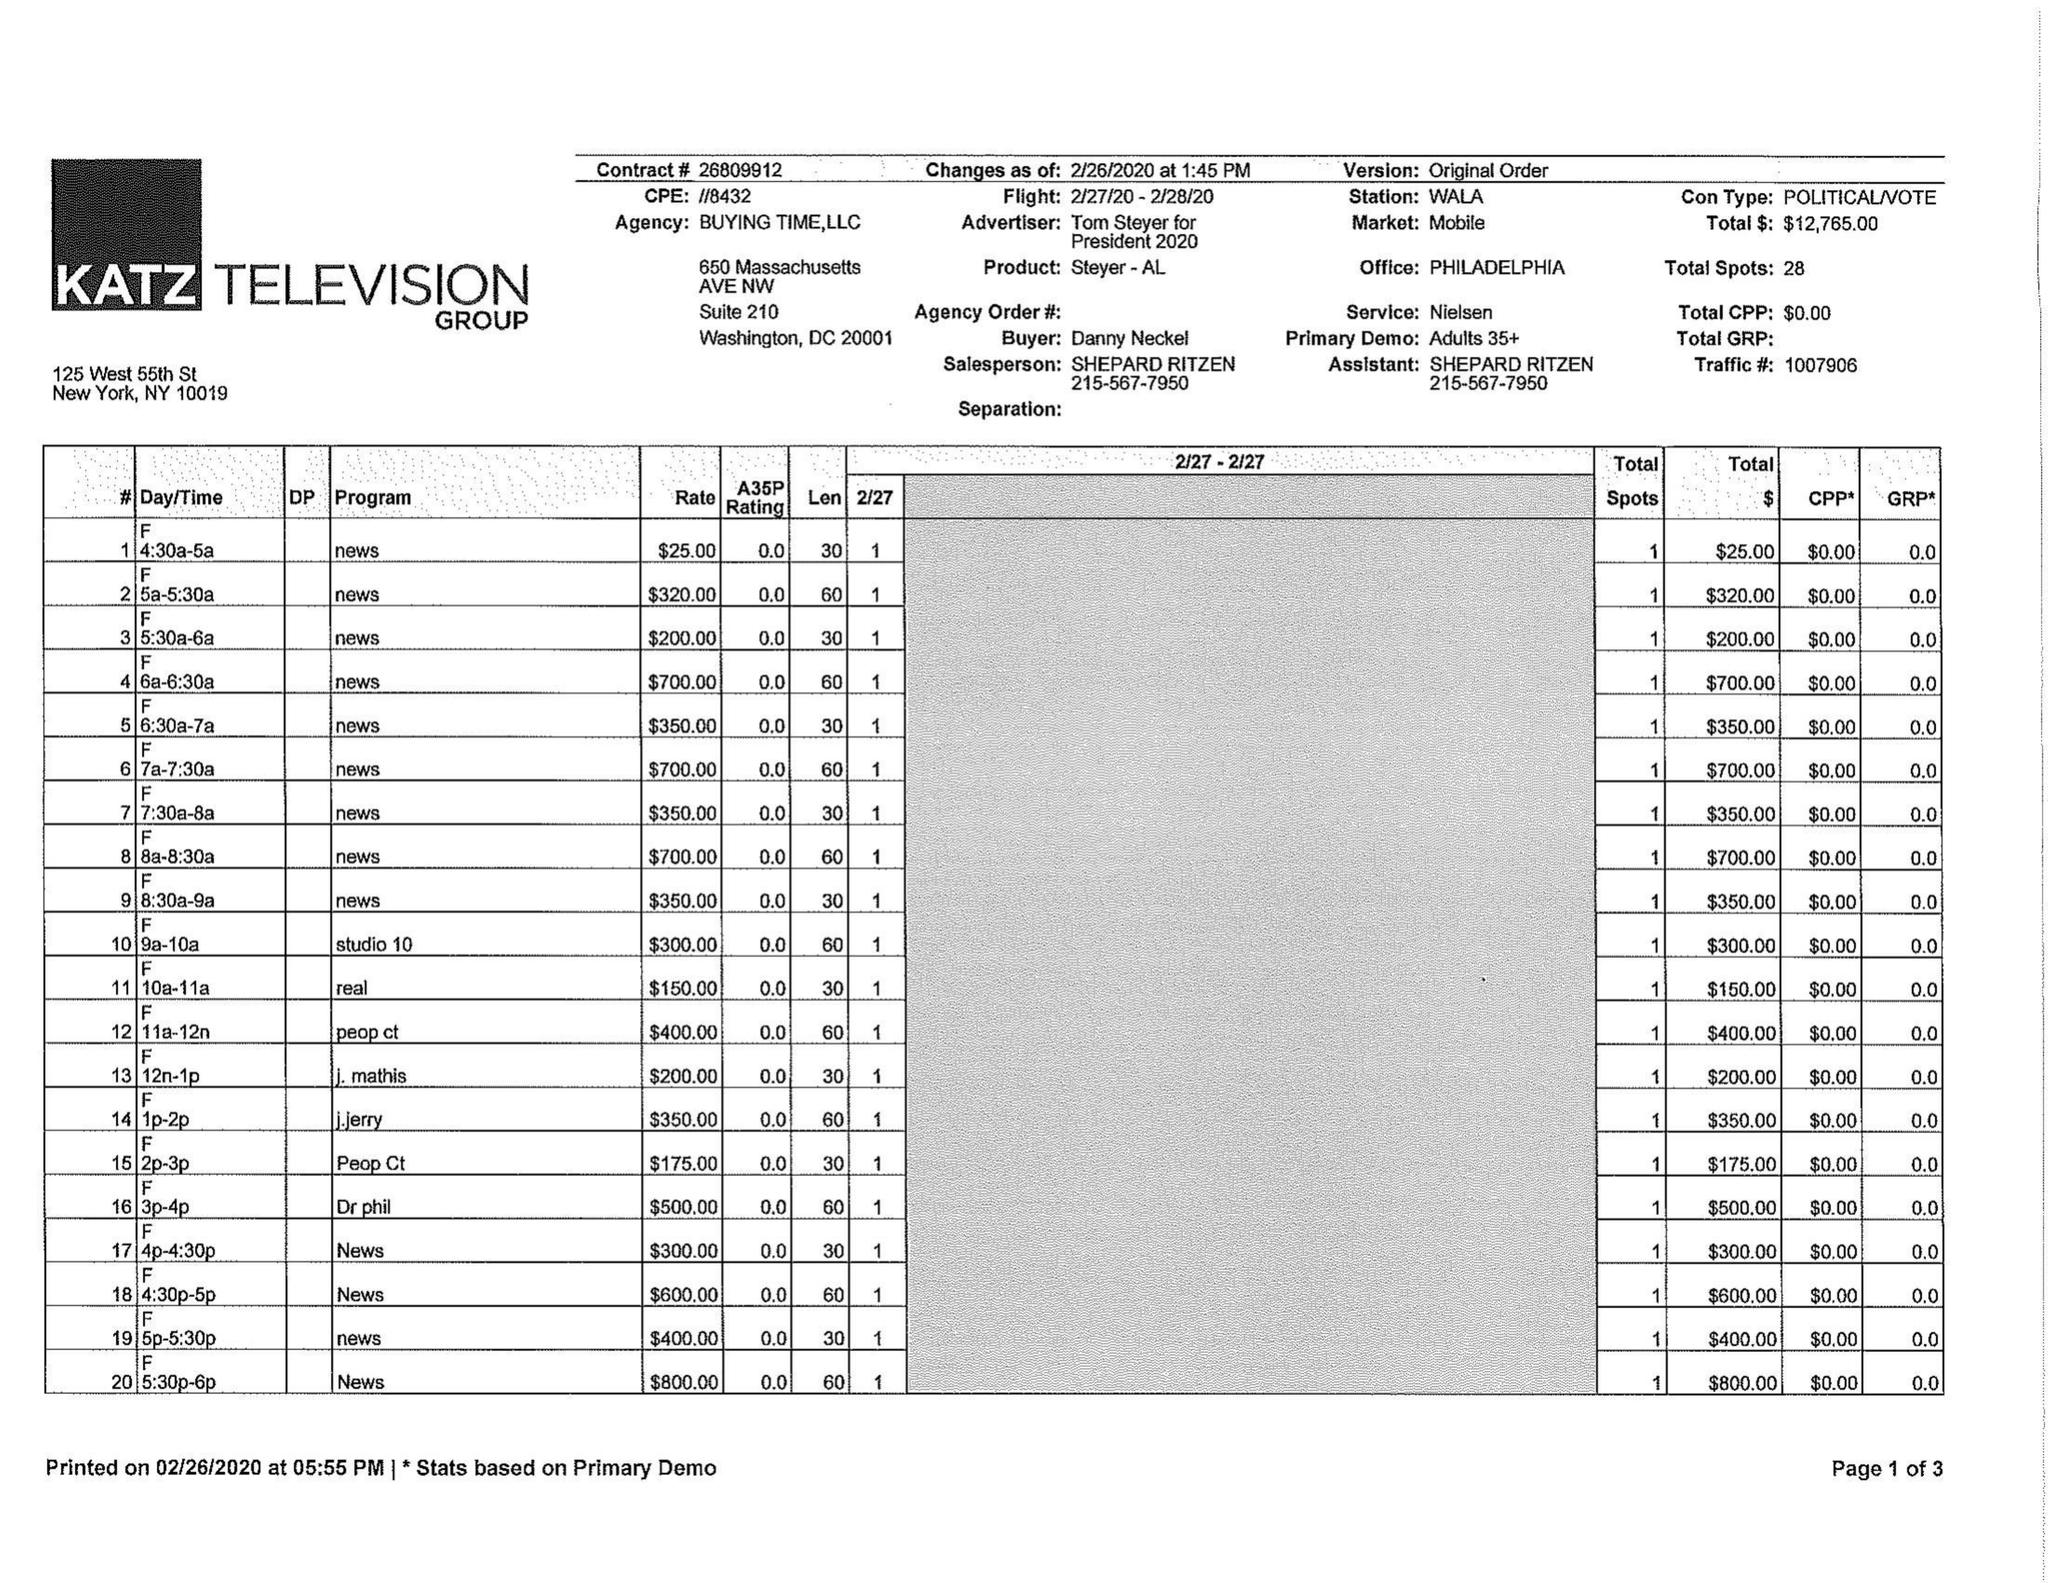What is the value for the flight_from?
Answer the question using a single word or phrase. 02/27/20 